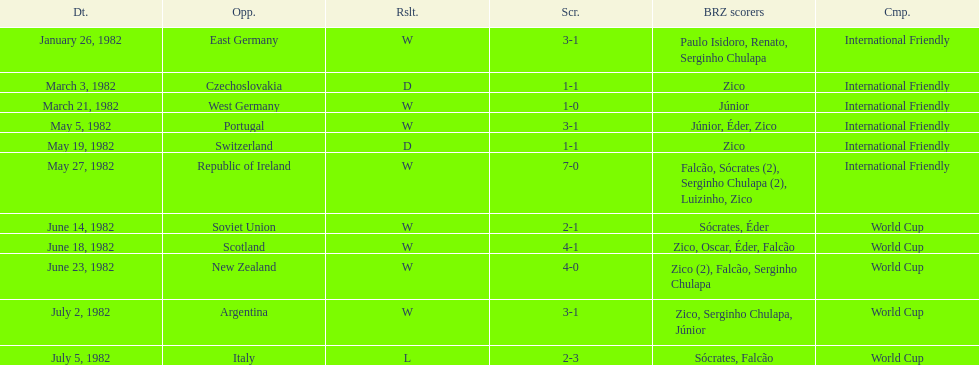Would you mind parsing the complete table? {'header': ['Dt.', 'Opp.', 'Rslt.', 'Scr.', 'BRZ scorers', 'Cmp.'], 'rows': [['January 26, 1982', 'East Germany', 'W', '3-1', 'Paulo Isidoro, Renato, Serginho Chulapa', 'International Friendly'], ['March 3, 1982', 'Czechoslovakia', 'D', '1-1', 'Zico', 'International Friendly'], ['March 21, 1982', 'West Germany', 'W', '1-0', 'Júnior', 'International Friendly'], ['May 5, 1982', 'Portugal', 'W', '3-1', 'Júnior, Éder, Zico', 'International Friendly'], ['May 19, 1982', 'Switzerland', 'D', '1-1', 'Zico', 'International Friendly'], ['May 27, 1982', 'Republic of Ireland', 'W', '7-0', 'Falcão, Sócrates (2), Serginho Chulapa (2), Luizinho, Zico', 'International Friendly'], ['June 14, 1982', 'Soviet Union', 'W', '2-1', 'Sócrates, Éder', 'World Cup'], ['June 18, 1982', 'Scotland', 'W', '4-1', 'Zico, Oscar, Éder, Falcão', 'World Cup'], ['June 23, 1982', 'New Zealand', 'W', '4-0', 'Zico (2), Falcão, Serginho Chulapa', 'World Cup'], ['July 2, 1982', 'Argentina', 'W', '3-1', 'Zico, Serginho Chulapa, Júnior', 'World Cup'], ['July 5, 1982', 'Italy', 'L', '2-3', 'Sócrates, Falcão', 'World Cup']]} What date is at the top of the list? January 26, 1982. 